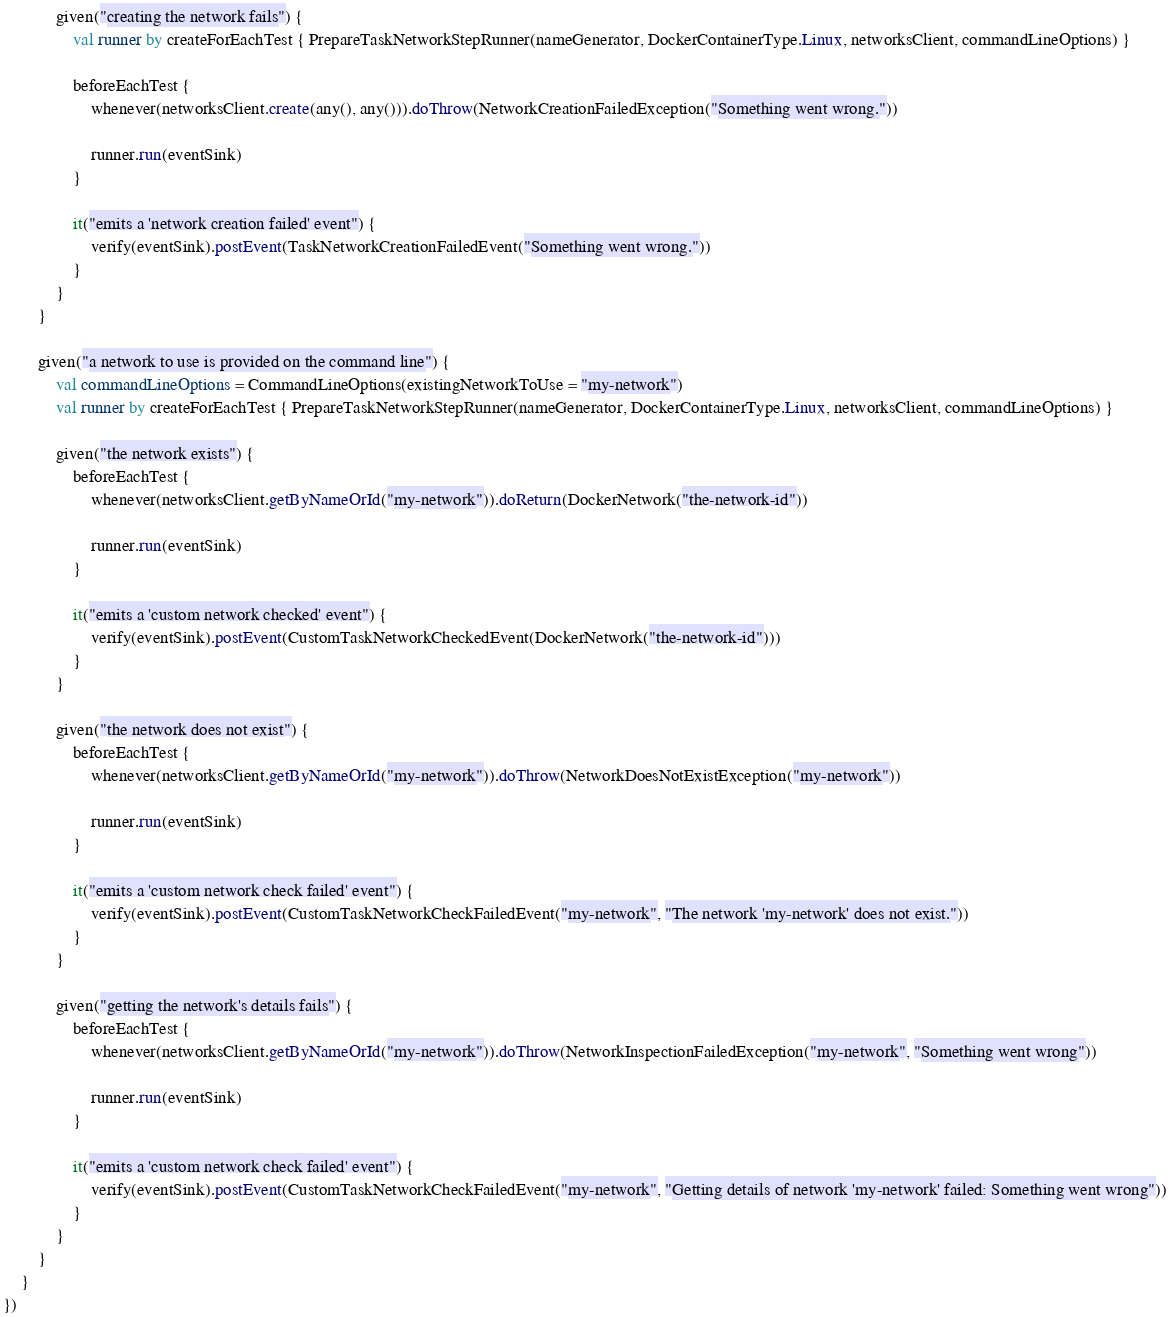<code> <loc_0><loc_0><loc_500><loc_500><_Kotlin_>            given("creating the network fails") {
                val runner by createForEachTest { PrepareTaskNetworkStepRunner(nameGenerator, DockerContainerType.Linux, networksClient, commandLineOptions) }

                beforeEachTest {
                    whenever(networksClient.create(any(), any())).doThrow(NetworkCreationFailedException("Something went wrong."))

                    runner.run(eventSink)
                }

                it("emits a 'network creation failed' event") {
                    verify(eventSink).postEvent(TaskNetworkCreationFailedEvent("Something went wrong."))
                }
            }
        }

        given("a network to use is provided on the command line") {
            val commandLineOptions = CommandLineOptions(existingNetworkToUse = "my-network")
            val runner by createForEachTest { PrepareTaskNetworkStepRunner(nameGenerator, DockerContainerType.Linux, networksClient, commandLineOptions) }

            given("the network exists") {
                beforeEachTest {
                    whenever(networksClient.getByNameOrId("my-network")).doReturn(DockerNetwork("the-network-id"))

                    runner.run(eventSink)
                }

                it("emits a 'custom network checked' event") {
                    verify(eventSink).postEvent(CustomTaskNetworkCheckedEvent(DockerNetwork("the-network-id")))
                }
            }

            given("the network does not exist") {
                beforeEachTest {
                    whenever(networksClient.getByNameOrId("my-network")).doThrow(NetworkDoesNotExistException("my-network"))

                    runner.run(eventSink)
                }

                it("emits a 'custom network check failed' event") {
                    verify(eventSink).postEvent(CustomTaskNetworkCheckFailedEvent("my-network", "The network 'my-network' does not exist."))
                }
            }

            given("getting the network's details fails") {
                beforeEachTest {
                    whenever(networksClient.getByNameOrId("my-network")).doThrow(NetworkInspectionFailedException("my-network", "Something went wrong"))

                    runner.run(eventSink)
                }

                it("emits a 'custom network check failed' event") {
                    verify(eventSink).postEvent(CustomTaskNetworkCheckFailedEvent("my-network", "Getting details of network 'my-network' failed: Something went wrong"))
                }
            }
        }
    }
})
</code> 